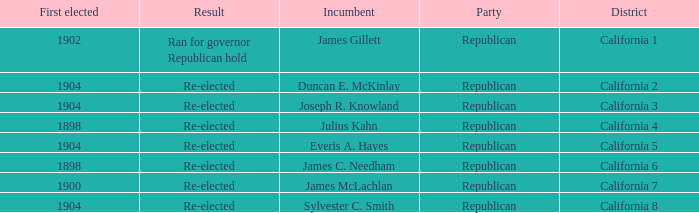Which Incumbent has a District of California 5? Everis A. Hayes. 